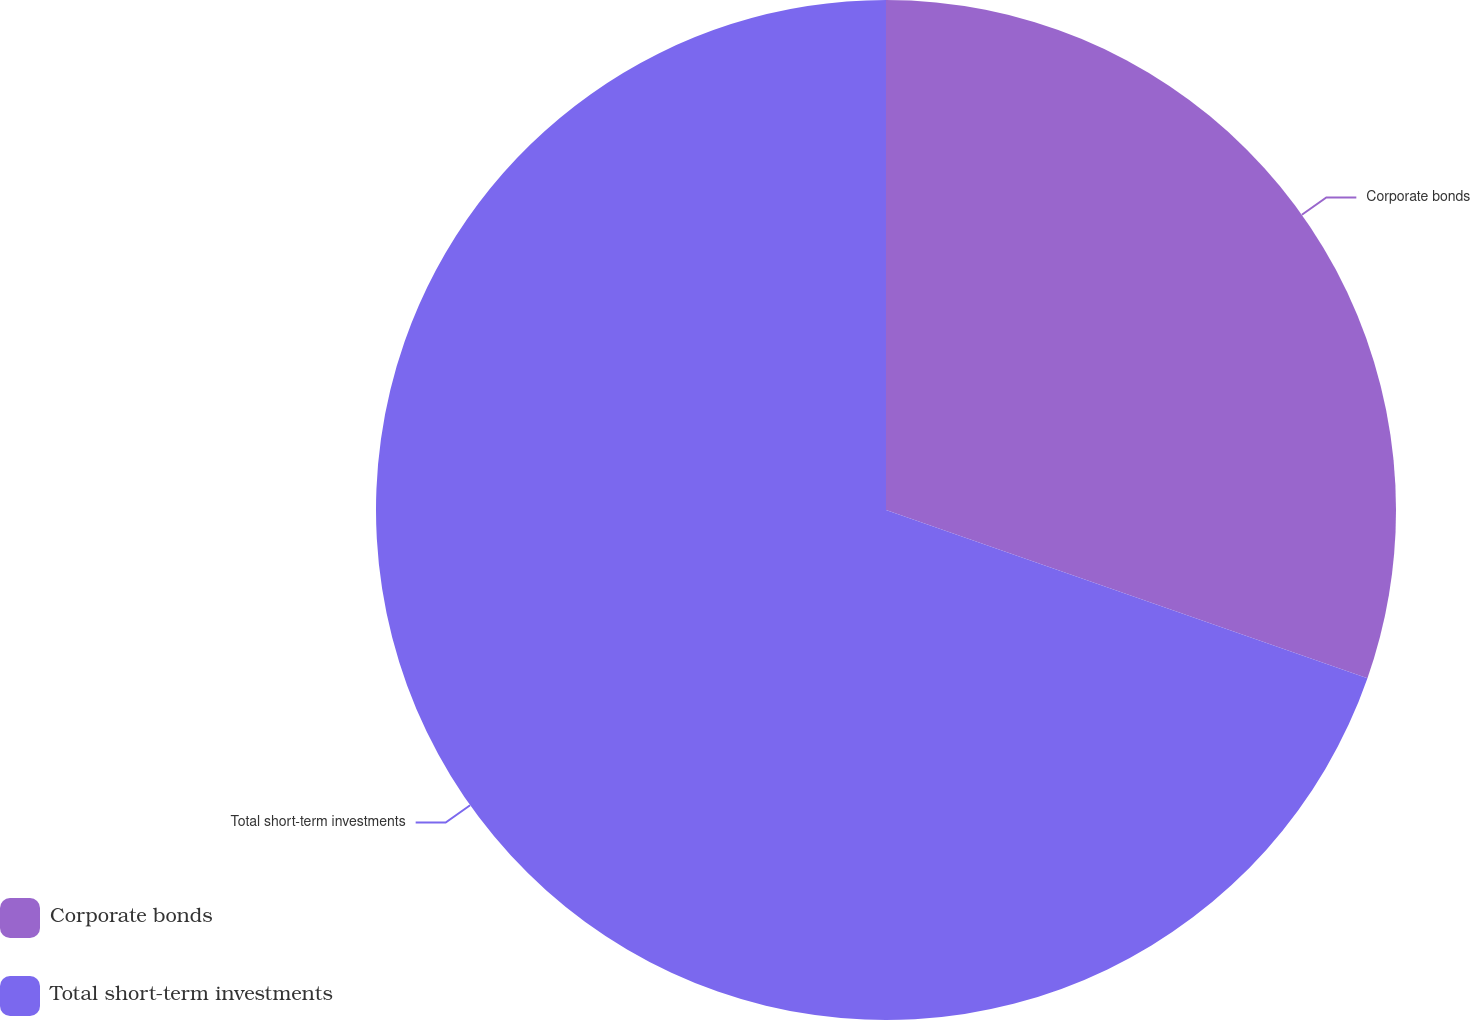<chart> <loc_0><loc_0><loc_500><loc_500><pie_chart><fcel>Corporate bonds<fcel>Total short-term investments<nl><fcel>30.35%<fcel>69.65%<nl></chart> 